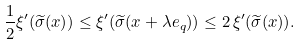<formula> <loc_0><loc_0><loc_500><loc_500>\frac { 1 } { 2 } \xi ^ { \prime } ( \widetilde { \sigma } ( x ) ) \leq \xi ^ { \prime } ( \widetilde { \sigma } ( x + \lambda e _ { q } ) ) \leq 2 \, \xi ^ { \prime } ( \widetilde { \sigma } ( x ) ) .</formula> 